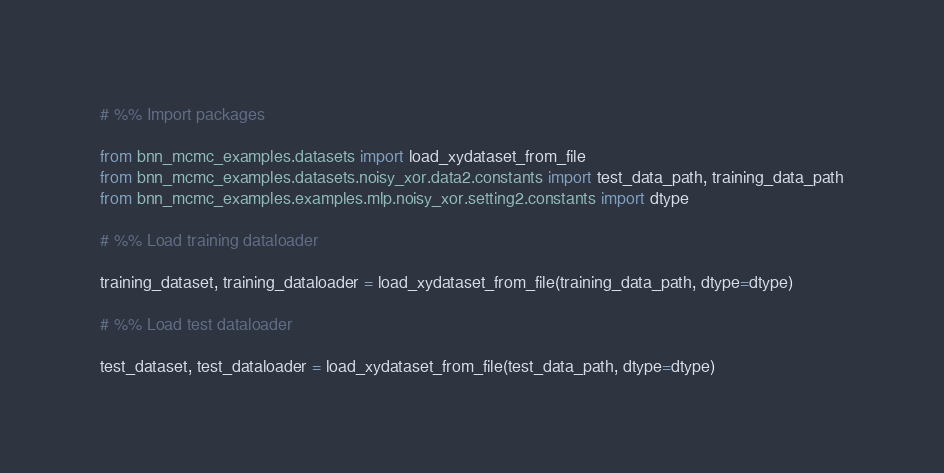<code> <loc_0><loc_0><loc_500><loc_500><_Python_># %% Import packages

from bnn_mcmc_examples.datasets import load_xydataset_from_file
from bnn_mcmc_examples.datasets.noisy_xor.data2.constants import test_data_path, training_data_path
from bnn_mcmc_examples.examples.mlp.noisy_xor.setting2.constants import dtype

# %% Load training dataloader

training_dataset, training_dataloader = load_xydataset_from_file(training_data_path, dtype=dtype)

# %% Load test dataloader

test_dataset, test_dataloader = load_xydataset_from_file(test_data_path, dtype=dtype)
</code> 